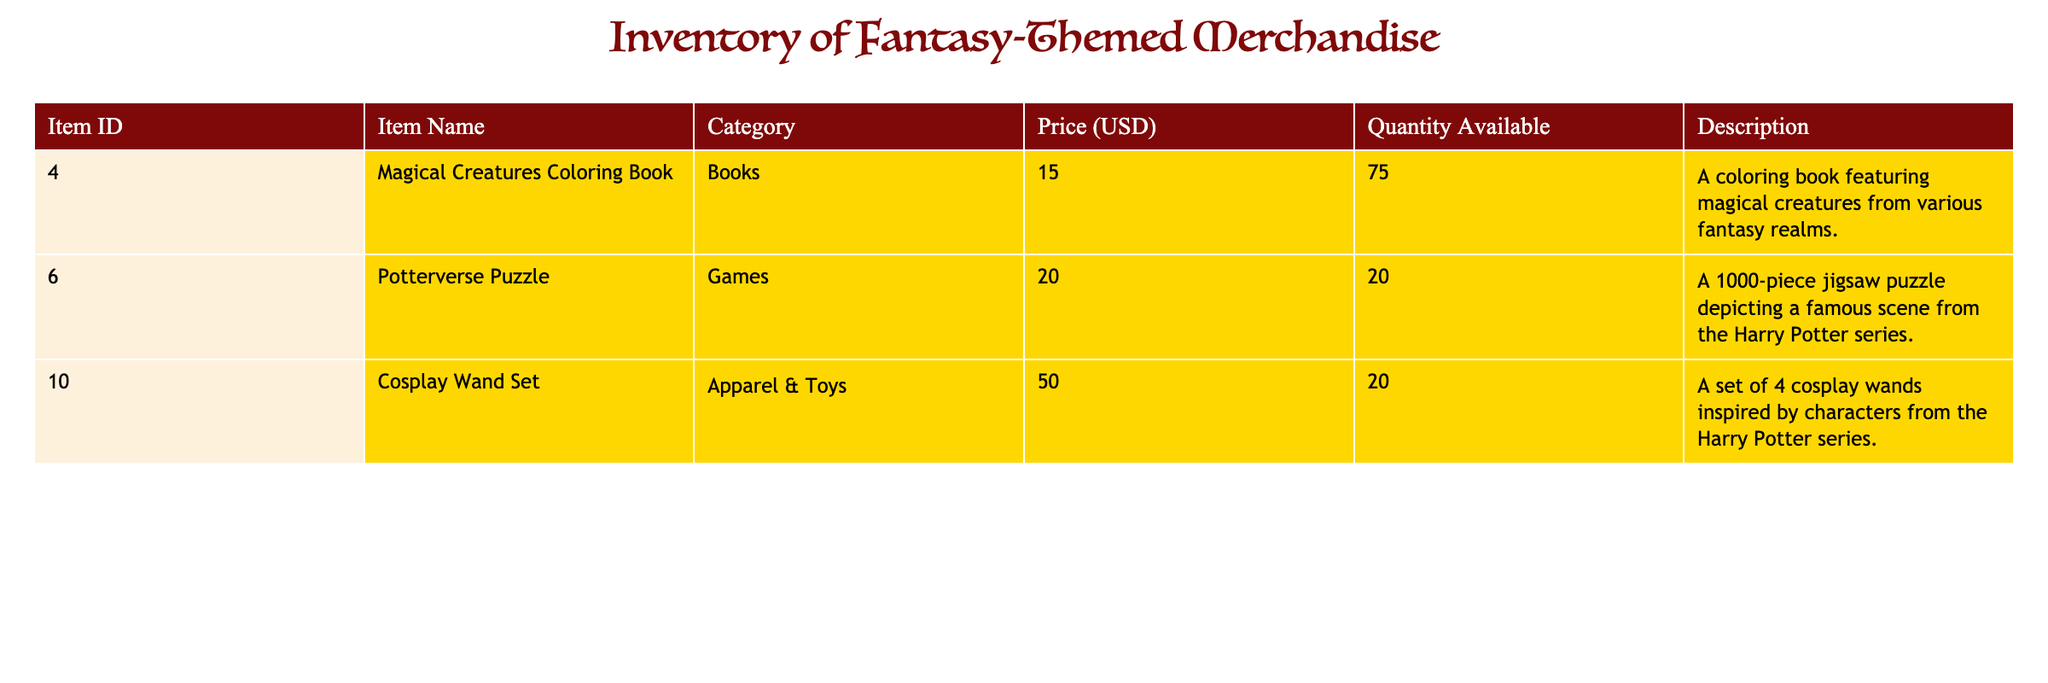What's the price of the Magical Creatures Coloring Book? The price is listed directly under the "Price (USD)" column corresponding to "Magical Creatures Coloring Book" in the table.
Answer: 15.00 How many Potterverse Puzzles are available? The quantity available is indicated in the "Quantity Available" column next to the "Potterverse Puzzle" row in the table.
Answer: 20 What is the total quantity of cosplay wands for sale? The total quantity is found in the "Quantity Available" column for the "Cosplay Wand Set" row, which is 20.
Answer: 20 Which item has the highest price and what is that price? The prices of all items are compared. The "Cosplay Wand Set" is 50.00, "Potterverse Puzzle" is 20.00, and "Magical Creatures Coloring Book" is 15.00. The highest price is for the "Cosplay Wand Set."
Answer: 50.00 Is the total quantity of the Magical Creatures Coloring Book greater than the Potterverse Puzzle? The quantity of "Magical Creatures Coloring Book" is 75, and for "Potterverse Puzzle" it is 20. Since 75 is greater than 20, the statement is true.
Answer: Yes What is the average price of all items in the inventory? The prices are 15.00, 20.00, and 50.00. Summing them gives 15.00 + 20.00 + 50.00 = 85.00, and dividing by 3 (the number of items) gives 85.00 / 3 ≈ 28.33.
Answer: 28.33 Are there any games listed in the inventory? Checking the "Category" column, the "Potterverse Puzzle" is classified under "Games," indicating that yes, there is at least one game listed.
Answer: Yes How many more Magical Creatures Coloring Books are available compared to Potterverse Puzzles? The quantity of "Magical Creatures Coloring Book" is 75, and "Potterverse Puzzle" is 20. Calculating the difference yields 75 - 20 = 55.
Answer: 55 What descriptions are given for the apparel & toys category? The "Cosplay Wand Set" is the only item in the "Apparel & Toys" category, and its description can be found under that specific row in the table.
Answer: A set of 4 cosplay wands inspired by characters from the Harry Potter series 